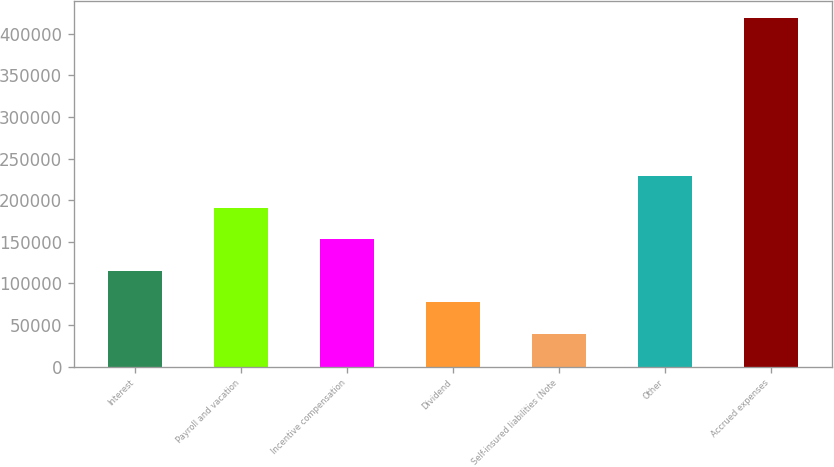<chart> <loc_0><loc_0><loc_500><loc_500><bar_chart><fcel>Interest<fcel>Payroll and vacation<fcel>Incentive compensation<fcel>Dividend<fcel>Self-insured liabilities (Note<fcel>Other<fcel>Accrued expenses<nl><fcel>115253<fcel>191147<fcel>153200<fcel>77305.3<fcel>39358<fcel>229094<fcel>418831<nl></chart> 